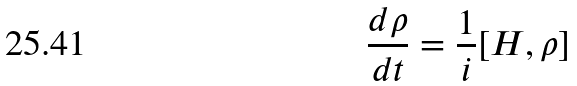<formula> <loc_0><loc_0><loc_500><loc_500>\frac { d \rho } { d t } = \frac { 1 } { i } [ H , \rho ]</formula> 